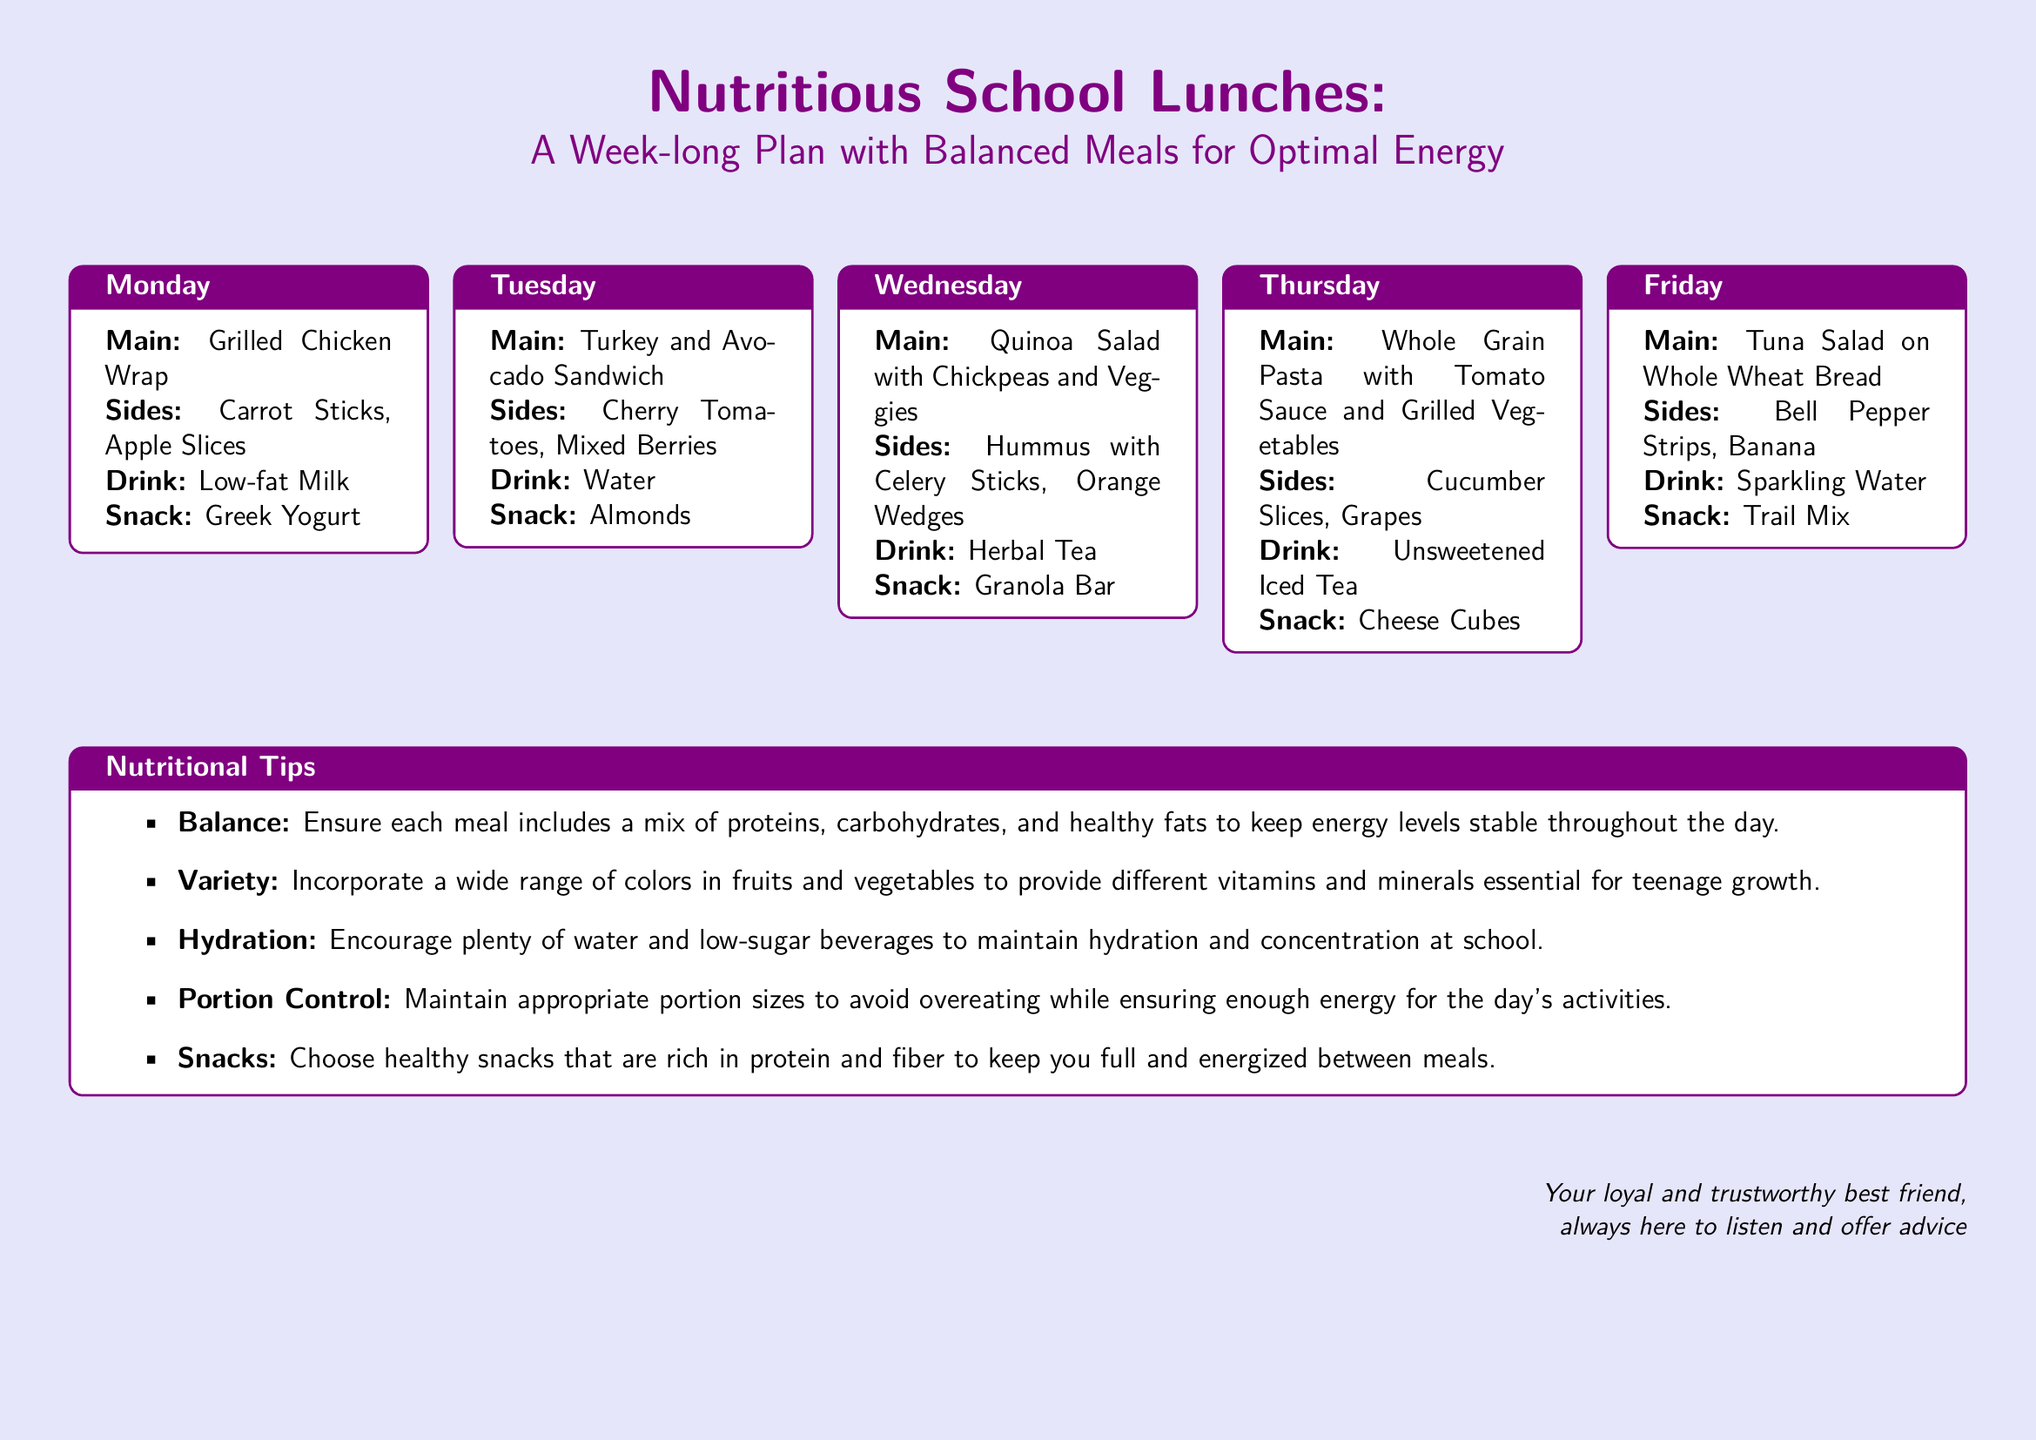What is the main dish for Monday? The main dish for Monday is listed under the Monday section of the meal plan.
Answer: Grilled Chicken Wrap What are the sides for Tuesday? The sides for Tuesday can be found in the Tuesday section of the meal plan.
Answer: Cherry Tomatoes, Mixed Berries Which drink is recommended for Wednesday? The drink for Wednesday is specified in the Wednesday section of the meal plan.
Answer: Herbal Tea What snack is paired with Thursday's meal? The snack for Thursday is mentioned in the Thursday section of the meal plan.
Answer: Cheese Cubes How many days does the meal plan cover? The document presents lunches for each weekday, which totals five days.
Answer: 5 What type of salad is served on Wednesday? The specifics of the salad on Wednesday is mentioned in the meal's main dish description.
Answer: Quinoa Salad with Chickpeas and Veggies Which beverage is suggested for Friday? The beverage for Friday is indicated in the Friday section of the meal plan.
Answer: Sparkling Water What is one of the nutritional tips provided? The document includes a list of nutritional tips that provides various suggestions.
Answer: Balance What is the definition of "Variety" in the nutritional tips? The description of "Variety" explains the importance of including diverse fruits and vegetables.
Answer: Incorporate a wide range of colors in fruits and vegetables 